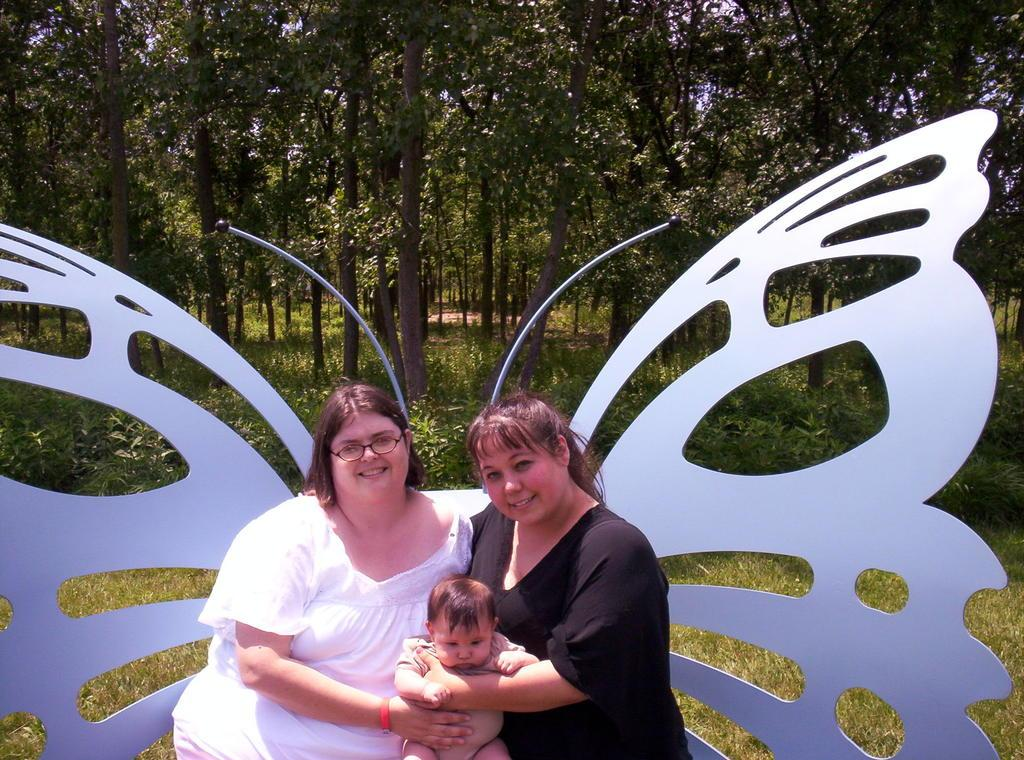How many women are in the picture? There are two women in the picture. What are the women doing in the image? The women are sitting in the image. What are the women holding? The women are holding a baby in the image. What shape can be seen behind the women? There is a butterfly shape behind the women in the image. What can be seen in the background of the image? There are trees in the background of the image. What type of skate is the baby wearing in the image? There is no skate present in the image; the baby is being held by the two women. 